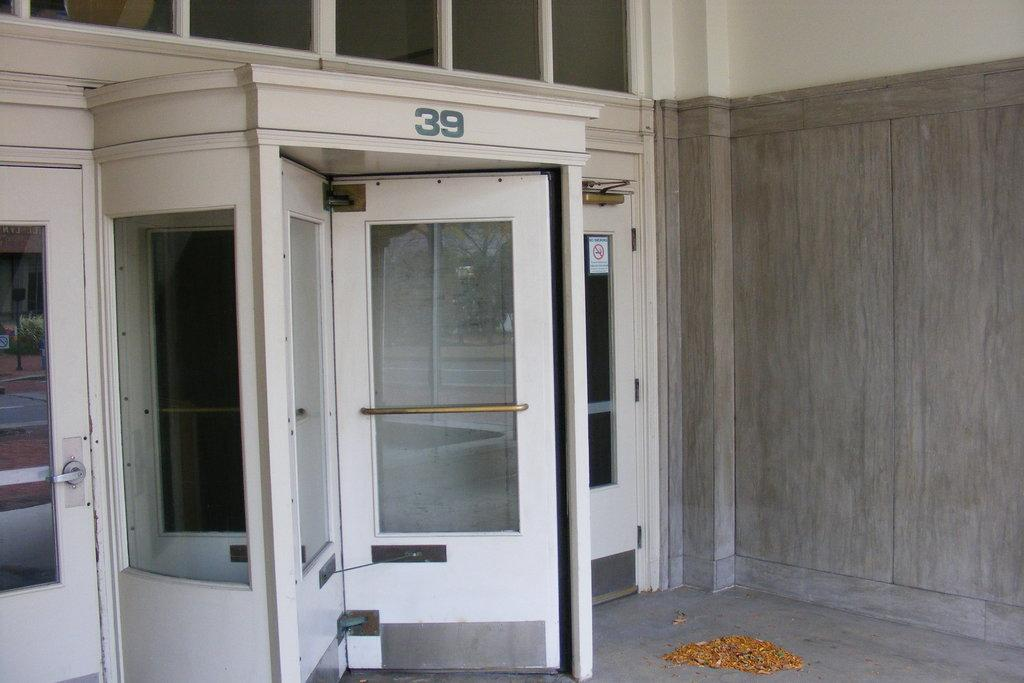<image>
Present a compact description of the photo's key features. A white revolving door is partially open and belongs to a building with the address of 39. 